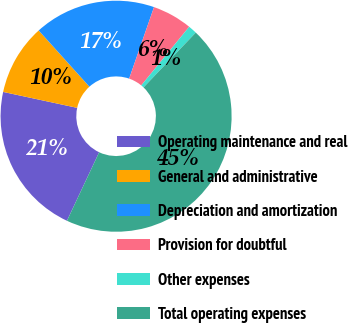<chart> <loc_0><loc_0><loc_500><loc_500><pie_chart><fcel>Operating maintenance and real<fcel>General and administrative<fcel>Depreciation and amortization<fcel>Provision for doubtful<fcel>Other expenses<fcel>Total operating expenses<nl><fcel>21.38%<fcel>9.94%<fcel>17.01%<fcel>5.58%<fcel>1.21%<fcel>44.87%<nl></chart> 